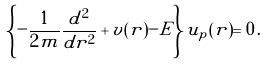Convert formula to latex. <formula><loc_0><loc_0><loc_500><loc_500>\left \{ - { \frac { 1 } { 2 m } } { \frac { d ^ { 2 } } { d r ^ { 2 } } } + v ( r ) - E \right \} u _ { p } ( r ) = 0 \, .</formula> 